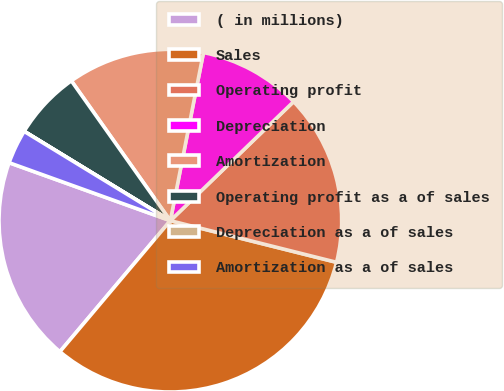<chart> <loc_0><loc_0><loc_500><loc_500><pie_chart><fcel>( in millions)<fcel>Sales<fcel>Operating profit<fcel>Depreciation<fcel>Amortization<fcel>Operating profit as a of sales<fcel>Depreciation as a of sales<fcel>Amortization as a of sales<nl><fcel>19.35%<fcel>32.24%<fcel>16.13%<fcel>9.68%<fcel>12.9%<fcel>6.46%<fcel>0.01%<fcel>3.23%<nl></chart> 